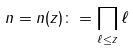Convert formula to latex. <formula><loc_0><loc_0><loc_500><loc_500>n = n ( z ) \colon = \prod _ { \ell \leq z } \ell</formula> 